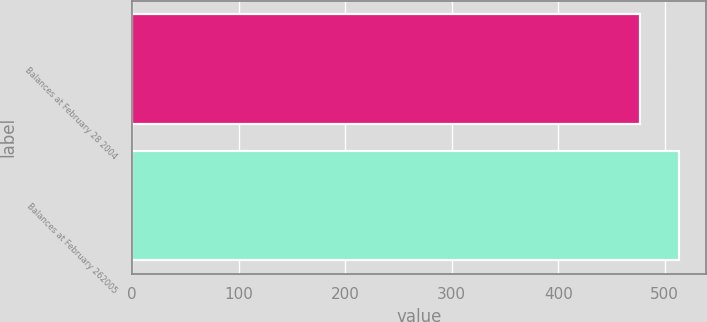Convert chart. <chart><loc_0><loc_0><loc_500><loc_500><bar_chart><fcel>Balances at February 28 2004<fcel>Balances at February 262005<nl><fcel>477<fcel>513<nl></chart> 